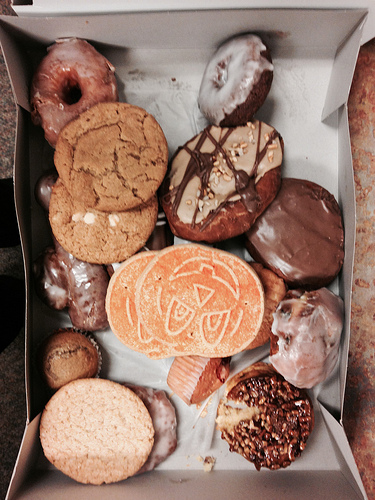<image>
Is the cookie on the cookie? Yes. Looking at the image, I can see the cookie is positioned on top of the cookie, with the cookie providing support. 